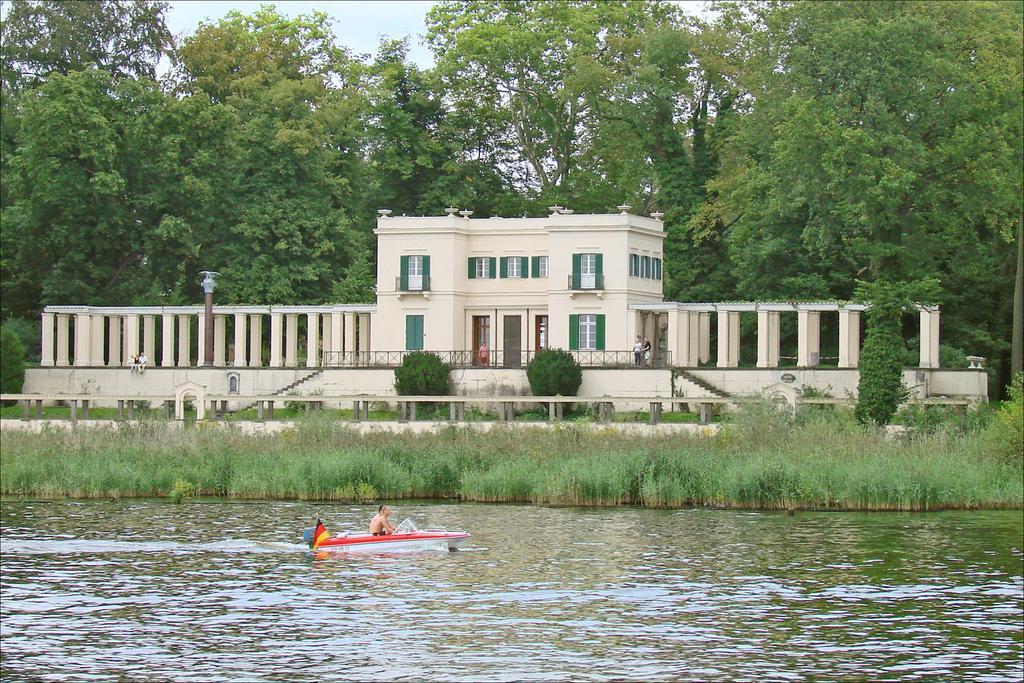In one or two sentences, can you explain what this image depicts? In the foreground of the image there are two people in the boat. At the bottom of the image there is water. In the background of the image there is a house, windows and doors. There are trees, plants. 